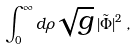Convert formula to latex. <formula><loc_0><loc_0><loc_500><loc_500>\int _ { 0 } ^ { \infty } d \rho \sqrt { g } \, | \tilde { \Phi } | ^ { 2 } \, ,</formula> 